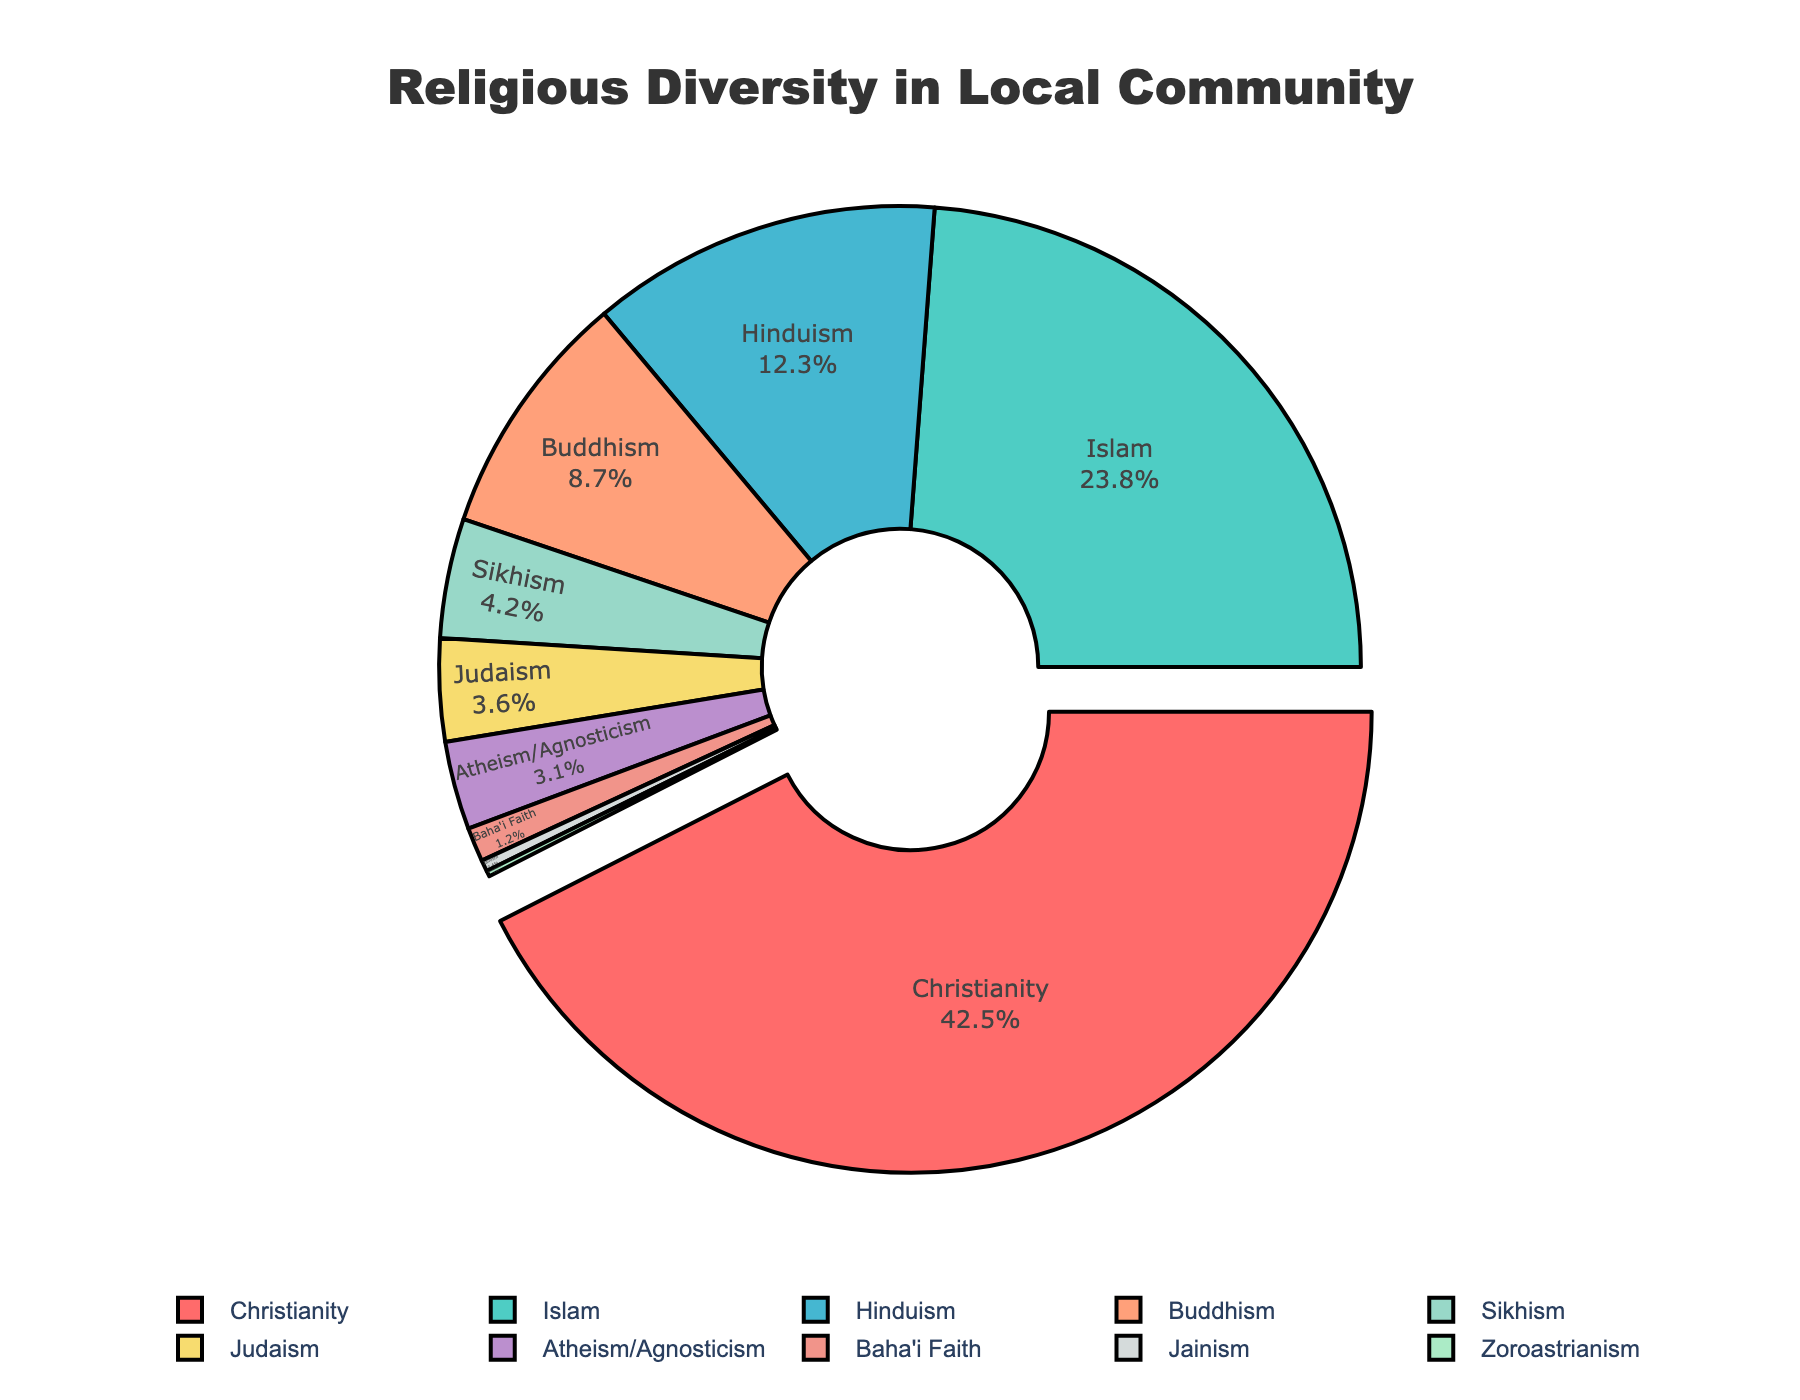What is the most represented religion in the local community? By referring to the pie chart labels and their percentages, Christianity has the largest segment of 42.5%.
Answer: Christianity Which religion has the smallest representation in the local community? The smallest segment in the pie chart is Zoroastrianism with 0.2%.
Answer: Zoroastrianism What percentage of the local community identifies as Hindu? The pie chart shows that the segment for Hinduism is 12.3%.
Answer: 12.3% How does the percentage of people who identify as Atheism/Agnosticism compare with those identifying as Sikhism? By referring to the pie chart, Atheism/Agnosticism has a percentage of 3.1%, while Sikhism has 4.2%. So, Sikhism is more represented.
Answer: Sikhism has a higher percentage What is the total percentage of people identifying as Christianity and Islam together? The percentages for Christianity and Islam are 42.5% and 23.8% respectively. Adding them up: 42.5 + 23.8 = 66.3%.
Answer: 66.3% Which religions have a representation of more than 10% in the local community? Referring to the pie chart, only Christianity (42.5%), Islam (23.8%), and Hinduism (12.3%) have more than 10%.
Answer: Christianity, Islam, Hinduism What is the difference in percentage between those who identify as Buddhism and those who identify as Judaism? The percentages are 8.7% for Buddhism and 3.6% for Judaism. The difference is 8.7 - 3.6 = 5.1%.
Answer: 5.1% What total percentage of the community identifies as either Judaism, Atheism/Agnosticism, or Baha'i Faith? Summing up the percentages: Judaism (3.6%) + Atheism/Agnosticism (3.1%) + Baha'i Faith (1.2%) = 3.6 + 3.1 + 1.2 = 7.9%.
Answer: 7.9% How does the size of the segment for Buddhism compare visually to the segment for Sikhism? Visually, the segment for Buddhism is larger than the segment for Sikhism.
Answer: Buddhism is larger What percentage of the local community practice minority religions (defined here as any religion with under 5% representation)? Add Jainism, Zoroastrianism, Baha'i Faith, Atheism/Agnosticism, Judaism, and Sikhism. Summing up the percentages for these religions: Jainism (0.4%), Zoroastrianism (0.2%), Baha'i Faith (1.2%), Atheism/Agnosticism (3.1%), Judaism (3.6%), and Sikhism (4.2%). 0.4 + 0.2 + 1.2 + 3.1 + 3.6 + 4.2 = 12.7%.
Answer: 12.7% 